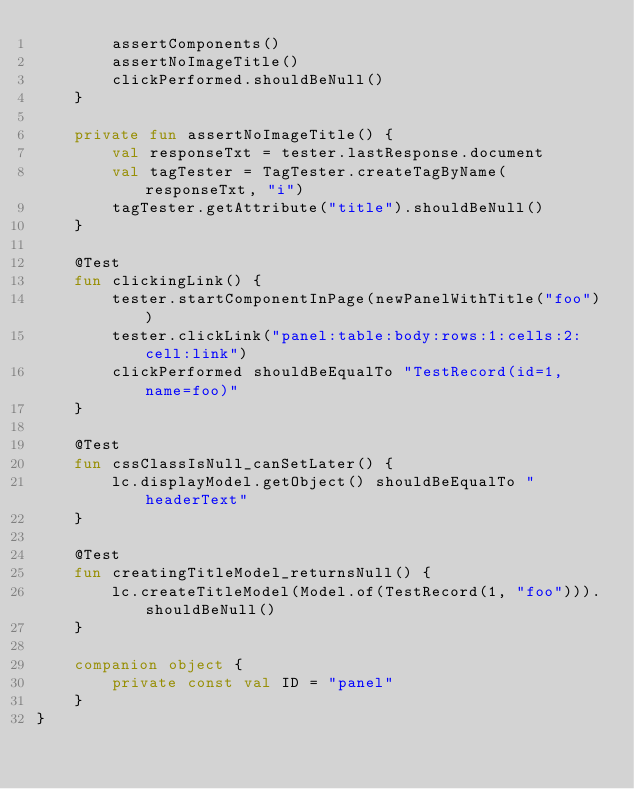Convert code to text. <code><loc_0><loc_0><loc_500><loc_500><_Kotlin_>        assertComponents()
        assertNoImageTitle()
        clickPerformed.shouldBeNull()
    }

    private fun assertNoImageTitle() {
        val responseTxt = tester.lastResponse.document
        val tagTester = TagTester.createTagByName(responseTxt, "i")
        tagTester.getAttribute("title").shouldBeNull()
    }

    @Test
    fun clickingLink() {
        tester.startComponentInPage(newPanelWithTitle("foo"))
        tester.clickLink("panel:table:body:rows:1:cells:2:cell:link")
        clickPerformed shouldBeEqualTo "TestRecord(id=1, name=foo)"
    }

    @Test
    fun cssClassIsNull_canSetLater() {
        lc.displayModel.getObject() shouldBeEqualTo "headerText"
    }

    @Test
    fun creatingTitleModel_returnsNull() {
        lc.createTitleModel(Model.of(TestRecord(1, "foo"))).shouldBeNull()
    }

    companion object {
        private const val ID = "panel"
    }
}
</code> 